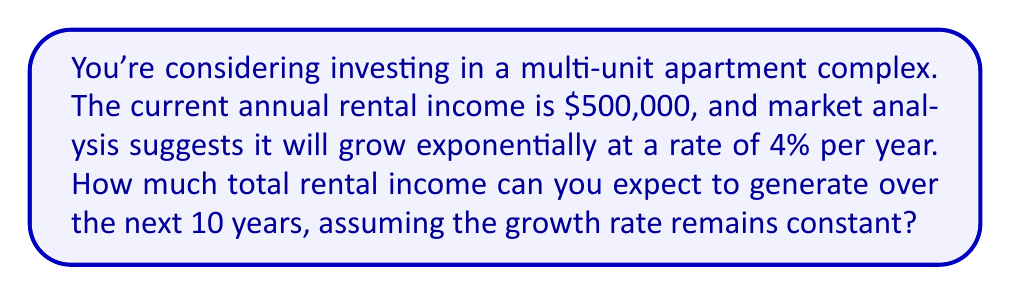Give your solution to this math problem. To solve this problem, we'll use the exponential growth formula and sum the rental income for each year. Let's break it down step-by-step:

1) The exponential growth formula is:
   $A(t) = A_0 \cdot (1 + r)^t$
   Where:
   $A(t)$ is the amount after time $t$
   $A_0$ is the initial amount
   $r$ is the growth rate
   $t$ is the time in years

2) In this case:
   $A_0 = \$500,000$
   $r = 0.04$ (4% expressed as a decimal)
   $t$ will range from 0 to 9 (as we include the current year)

3) We need to calculate the rental income for each year and sum them:

   $\sum_{t=0}^9 500000 \cdot (1.04)^t$

4) Let's expand this:
   $500000 \cdot (1.04)^0 + 500000 \cdot (1.04)^1 + ... + 500000 \cdot (1.04)^9$

5) This is a geometric series with:
   First term $a = 500000$
   Common ratio $r = 1.04$
   Number of terms $n = 10$

6) The sum of a geometric series is given by:
   $S_n = a \cdot \frac{1-r^n}{1-r}$ when $r \neq 1$

7) Plugging in our values:
   $S_{10} = 500000 \cdot \frac{1-(1.04)^{10}}{1-1.04}$

8) Simplifying:
   $S_{10} = 500000 \cdot \frac{1-1.4802}{-0.04} = 500000 \cdot 12.006$

9) Calculating the final result:
   $S_{10} = 6,003,000$

Therefore, the total rental income over the next 10 years would be approximately $6,003,000.
Answer: $6,003,000 